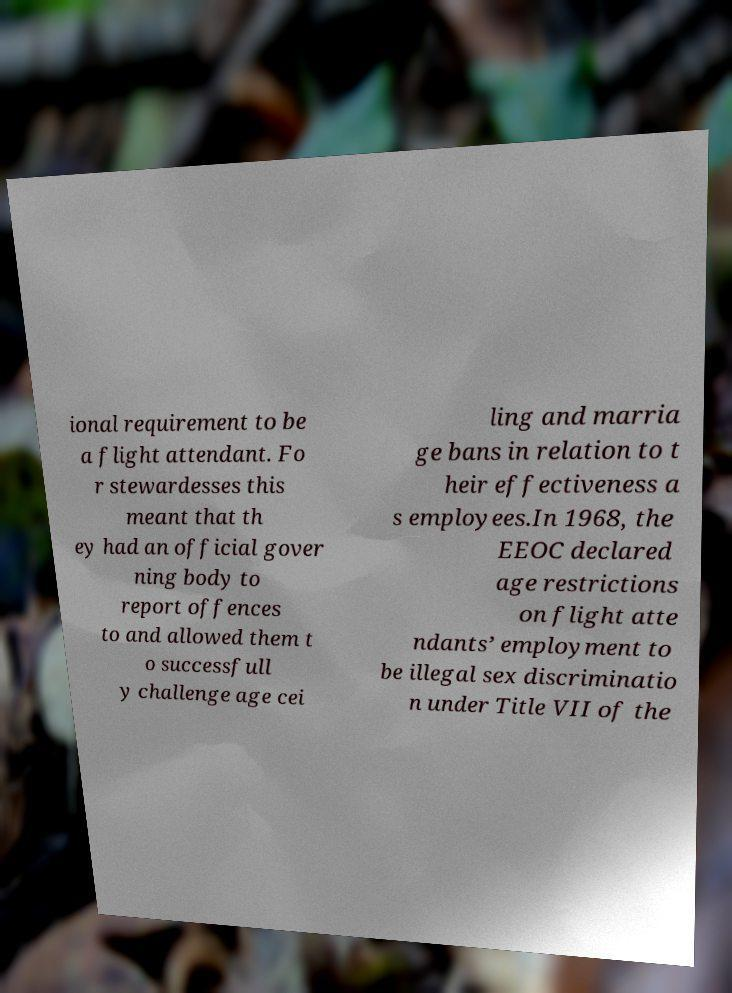There's text embedded in this image that I need extracted. Can you transcribe it verbatim? ional requirement to be a flight attendant. Fo r stewardesses this meant that th ey had an official gover ning body to report offences to and allowed them t o successfull y challenge age cei ling and marria ge bans in relation to t heir effectiveness a s employees.In 1968, the EEOC declared age restrictions on flight atte ndants’ employment to be illegal sex discriminatio n under Title VII of the 